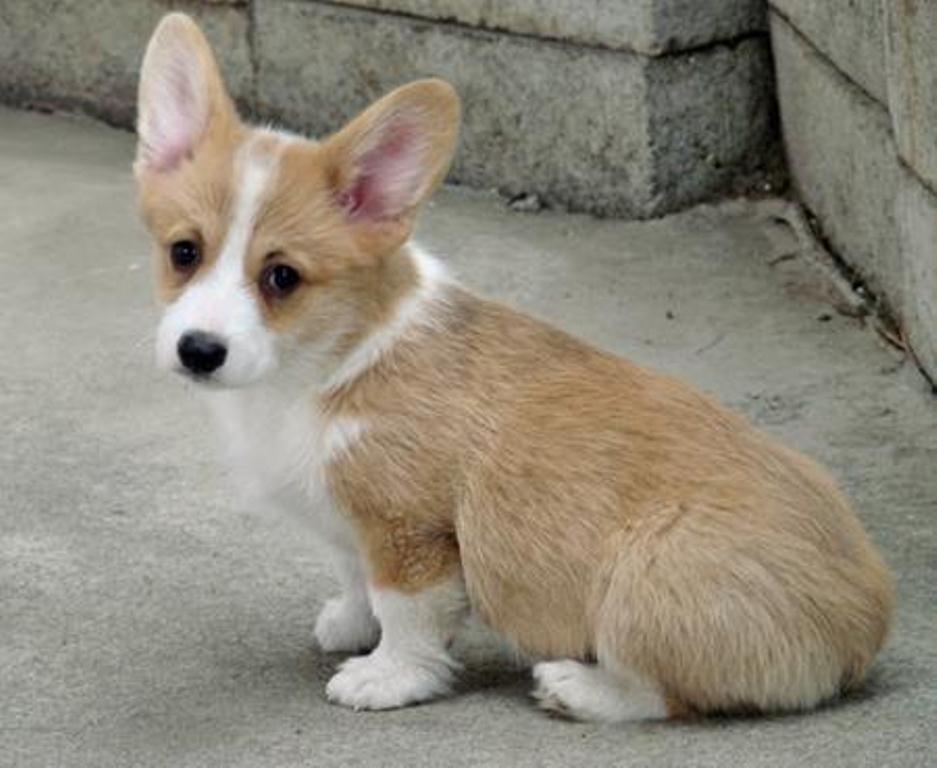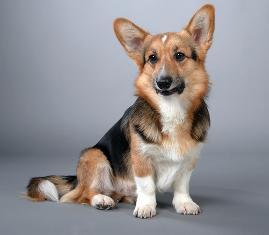The first image is the image on the left, the second image is the image on the right. Assess this claim about the two images: "There are four dogs in the image pair.". Correct or not? Answer yes or no. No. The first image is the image on the left, the second image is the image on the right. Analyze the images presented: Is the assertion "The left image contains exactly two dogs." valid? Answer yes or no. No. 